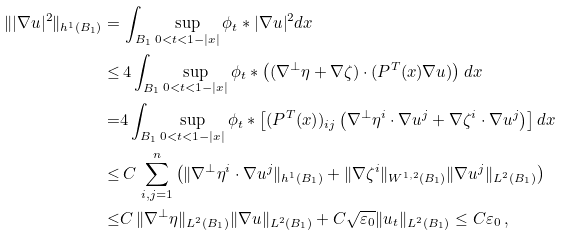<formula> <loc_0><loc_0><loc_500><loc_500>\| | \nabla u | ^ { 2 } \| _ { h ^ { 1 } ( B _ { 1 } ) } = & \, \int _ { B _ { 1 } } \sup _ { 0 < t < 1 - | x | } \phi _ { t } \ast | \nabla u | ^ { 2 } d x \\ \leq & \, 4 \int _ { B _ { 1 } } \sup _ { 0 < t < 1 - | x | } \phi _ { t } \ast \left ( ( \nabla ^ { \perp } \eta + \nabla \zeta ) \cdot ( P ^ { T } ( x ) \nabla u ) \right ) d x \\ = & 4 \int _ { B _ { 1 } } \sup _ { 0 < t < 1 - | x | } \phi _ { t } \ast \left [ ( P ^ { T } ( x ) ) _ { i j } \left ( \nabla ^ { \perp } \eta ^ { i } \cdot \nabla u ^ { j } + \nabla \zeta ^ { i } \cdot \nabla u ^ { j } \right ) \right ] d x \\ \leq & \, C \, \sum _ { i , j = 1 } ^ { n } \left ( \| \nabla ^ { \perp } \eta ^ { i } \cdot \nabla u ^ { j } \| _ { h ^ { 1 } ( B _ { 1 } ) } + \| \nabla \zeta ^ { i } \| _ { W ^ { 1 , 2 } ( B _ { 1 } ) } \| \nabla u ^ { j } \| _ { L ^ { 2 } ( B _ { 1 } ) } \right ) \\ \leq & C \, \| \nabla ^ { \perp } \eta \| _ { L ^ { 2 } ( B _ { 1 } ) } \| \nabla u \| _ { L ^ { 2 } ( B _ { 1 } ) } + C \sqrt { \varepsilon _ { 0 } } \| u _ { t } \| _ { L ^ { 2 } ( B _ { 1 } ) } \leq C \varepsilon _ { 0 } \, ,</formula> 